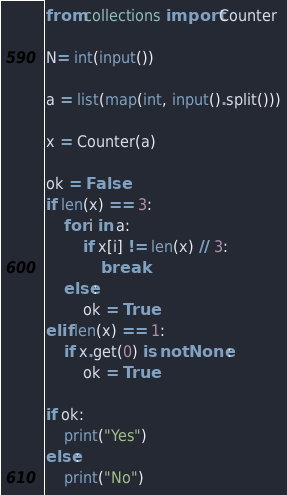<code> <loc_0><loc_0><loc_500><loc_500><_Python_>from collections import Counter

N= int(input())

a = list(map(int, input().split()))

x = Counter(a)

ok = False
if len(x) == 3:
    for i in a:
        if x[i] != len(x) // 3:
            break
    else:
        ok = True
elif len(x) == 1:
    if x.get(0) is not None:
        ok = True

if ok:
    print("Yes")
else:
    print("No")
</code> 